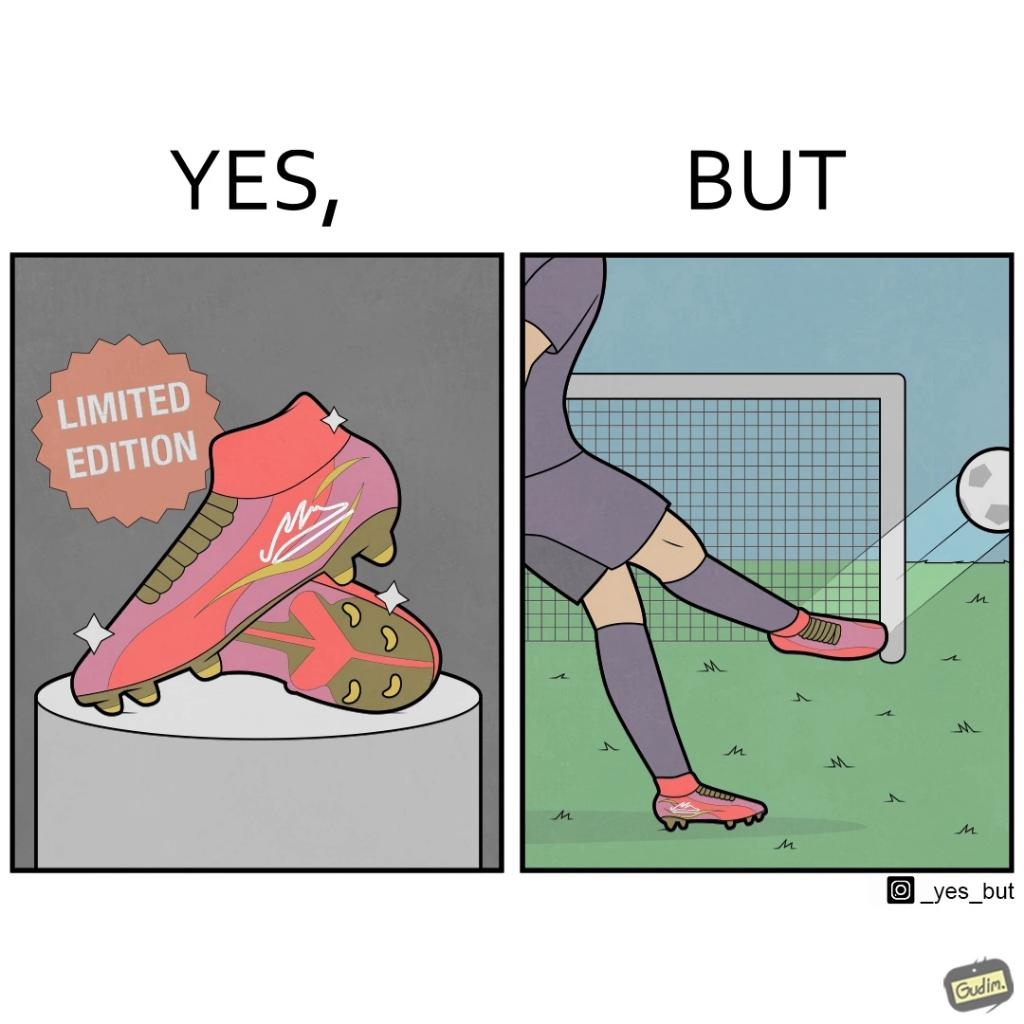What is shown in this image? The images are funny since they show how wearing expensive football boots does not make the user a better footballer. The footballer is still just as bad and it is a waste for him to buy such expensive boots 